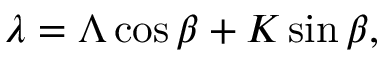Convert formula to latex. <formula><loc_0><loc_0><loc_500><loc_500>\lambda = \Lambda \cos { \beta } + K \sin { \beta } ,</formula> 